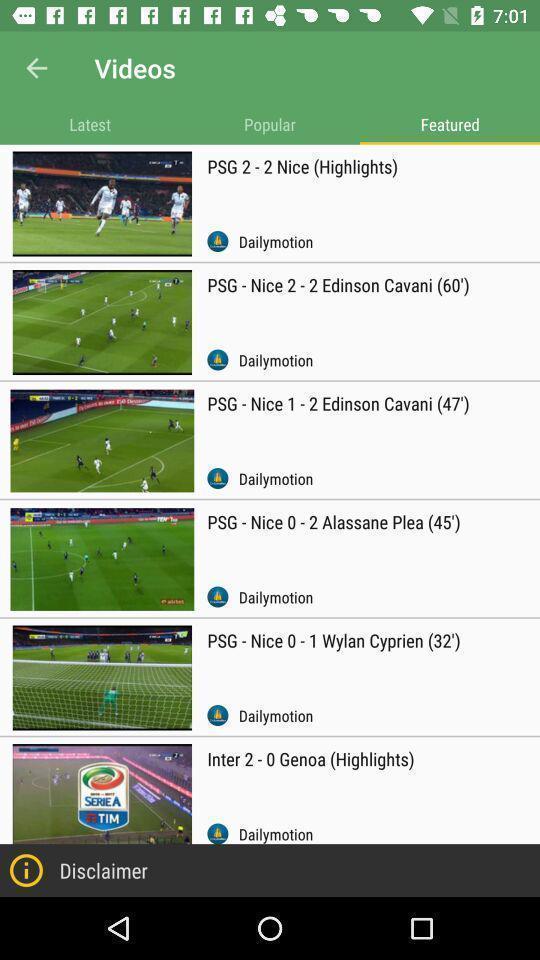Summarize the main components in this picture. Screen displaying list of sports videos. 